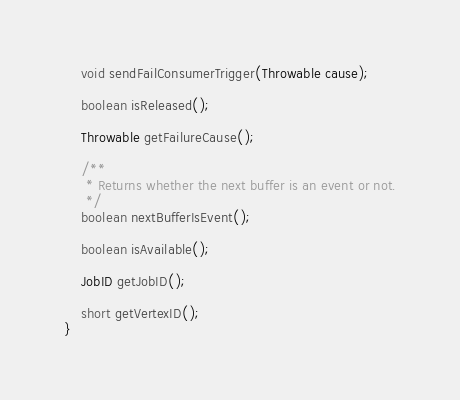<code> <loc_0><loc_0><loc_500><loc_500><_Java_>
	void sendFailConsumerTrigger(Throwable cause);

	boolean isReleased();

	Throwable getFailureCause();

	/**
	 * Returns whether the next buffer is an event or not.
	 */
	boolean nextBufferIsEvent();

	boolean isAvailable();

    JobID getJobID();

    short getVertexID();
}
</code> 